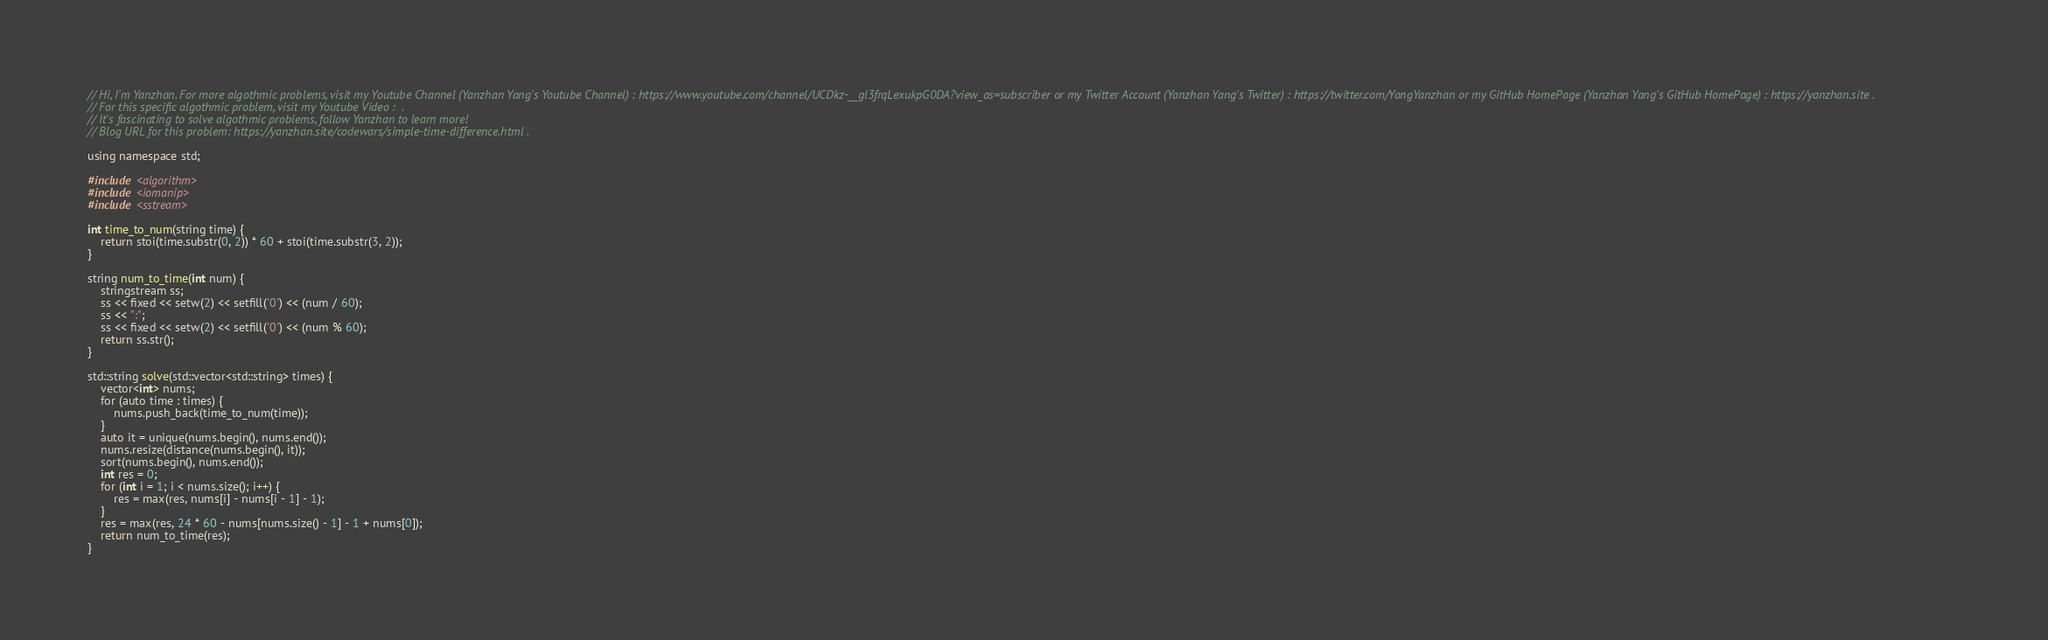Convert code to text. <code><loc_0><loc_0><loc_500><loc_500><_C++_>// Hi, I'm Yanzhan. For more algothmic problems, visit my Youtube Channel (Yanzhan Yang's Youtube Channel) : https://www.youtube.com/channel/UCDkz-__gl3frqLexukpG0DA?view_as=subscriber or my Twitter Account (Yanzhan Yang's Twitter) : https://twitter.com/YangYanzhan or my GitHub HomePage (Yanzhan Yang's GitHub HomePage) : https://yanzhan.site .
// For this specific algothmic problem, visit my Youtube Video :  .
// It's fascinating to solve algothmic problems, follow Yanzhan to learn more!
// Blog URL for this problem: https://yanzhan.site/codewars/simple-time-difference.html .

using namespace std;

#include <algorithm>
#include <iomanip>
#include <sstream>

int time_to_num(string time) {
    return stoi(time.substr(0, 2)) * 60 + stoi(time.substr(3, 2));
}

string num_to_time(int num) {
    stringstream ss;
    ss << fixed << setw(2) << setfill('0') << (num / 60);
    ss << ":";
    ss << fixed << setw(2) << setfill('0') << (num % 60);
    return ss.str();
}

std::string solve(std::vector<std::string> times) {
    vector<int> nums;
    for (auto time : times) {
        nums.push_back(time_to_num(time));
    }
    auto it = unique(nums.begin(), nums.end());
    nums.resize(distance(nums.begin(), it));
    sort(nums.begin(), nums.end());
    int res = 0;
    for (int i = 1; i < nums.size(); i++) {
        res = max(res, nums[i] - nums[i - 1] - 1);
    }
    res = max(res, 24 * 60 - nums[nums.size() - 1] - 1 + nums[0]);
    return num_to_time(res);
}
</code> 